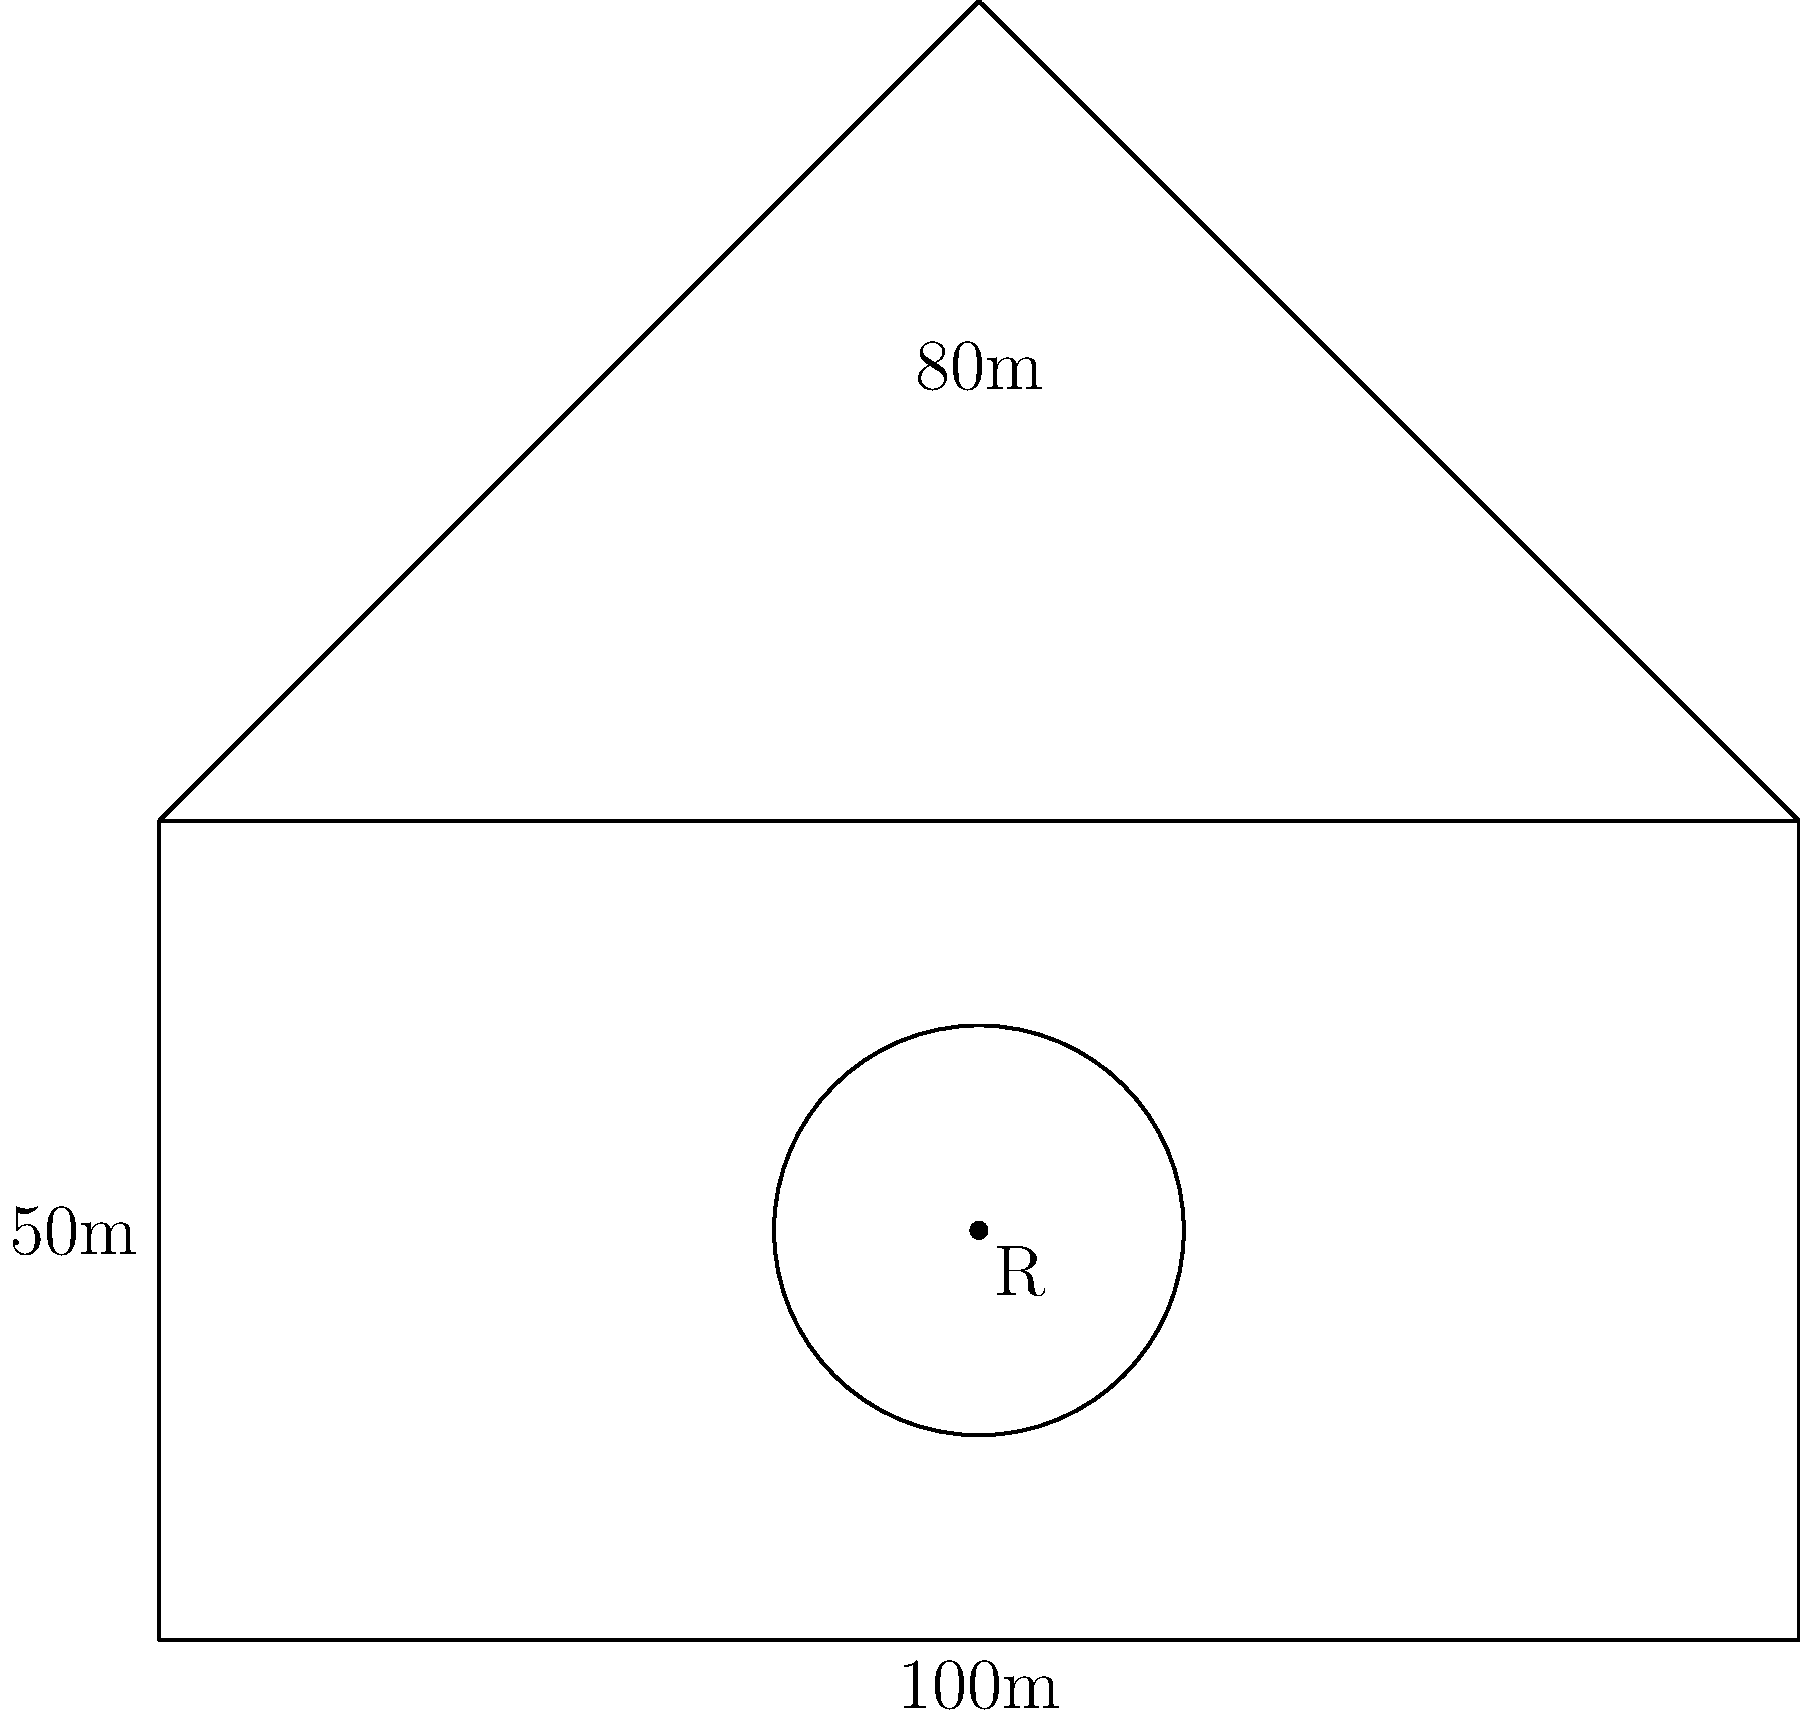As a rising executive at a prestigious Wall Street firm, you've been tasked with calculating the total perimeter of your company's new corporate campus. The campus consists of a rectangular base with dimensions 100m by 50m, topped by an isosceles triangle with a height of 40m. Additionally, there's a circular courtyard with radius R in the center of the rectangular base. If the total perimeter of the entire structure (including the courtyard) is 372m, what is the radius R of the circular courtyard? Let's approach this step-by-step:

1) First, let's calculate the perimeter of the rectangular base and triangular top without the courtyard:

   Rectangle: $2(100m + 50m) = 300m$
   Triangle: $2\sqrt{40^2 + 50^2} + 100 = 2\sqrt{4100} + 100 \approx 228.11m$

   Total: $300m + 228.11m = 528.11m$

2) The given total perimeter (372m) includes the courtyard. The difference between our calculated perimeter and the given perimeter is the length that the courtyard adds:

   $528.11m - 372m = 156.11m$

3) This 156.11m is the outer circumference of the circular courtyard. We can use the formula for circumference to find the radius:

   $C = 2\pi R$
   $156.11 = 2\pi R$

4) Solving for R:

   $R = \frac{156.11}{2\pi} \approx 24.84m$

Therefore, the radius of the circular courtyard is approximately 24.84 meters.
Answer: $24.84m$ 